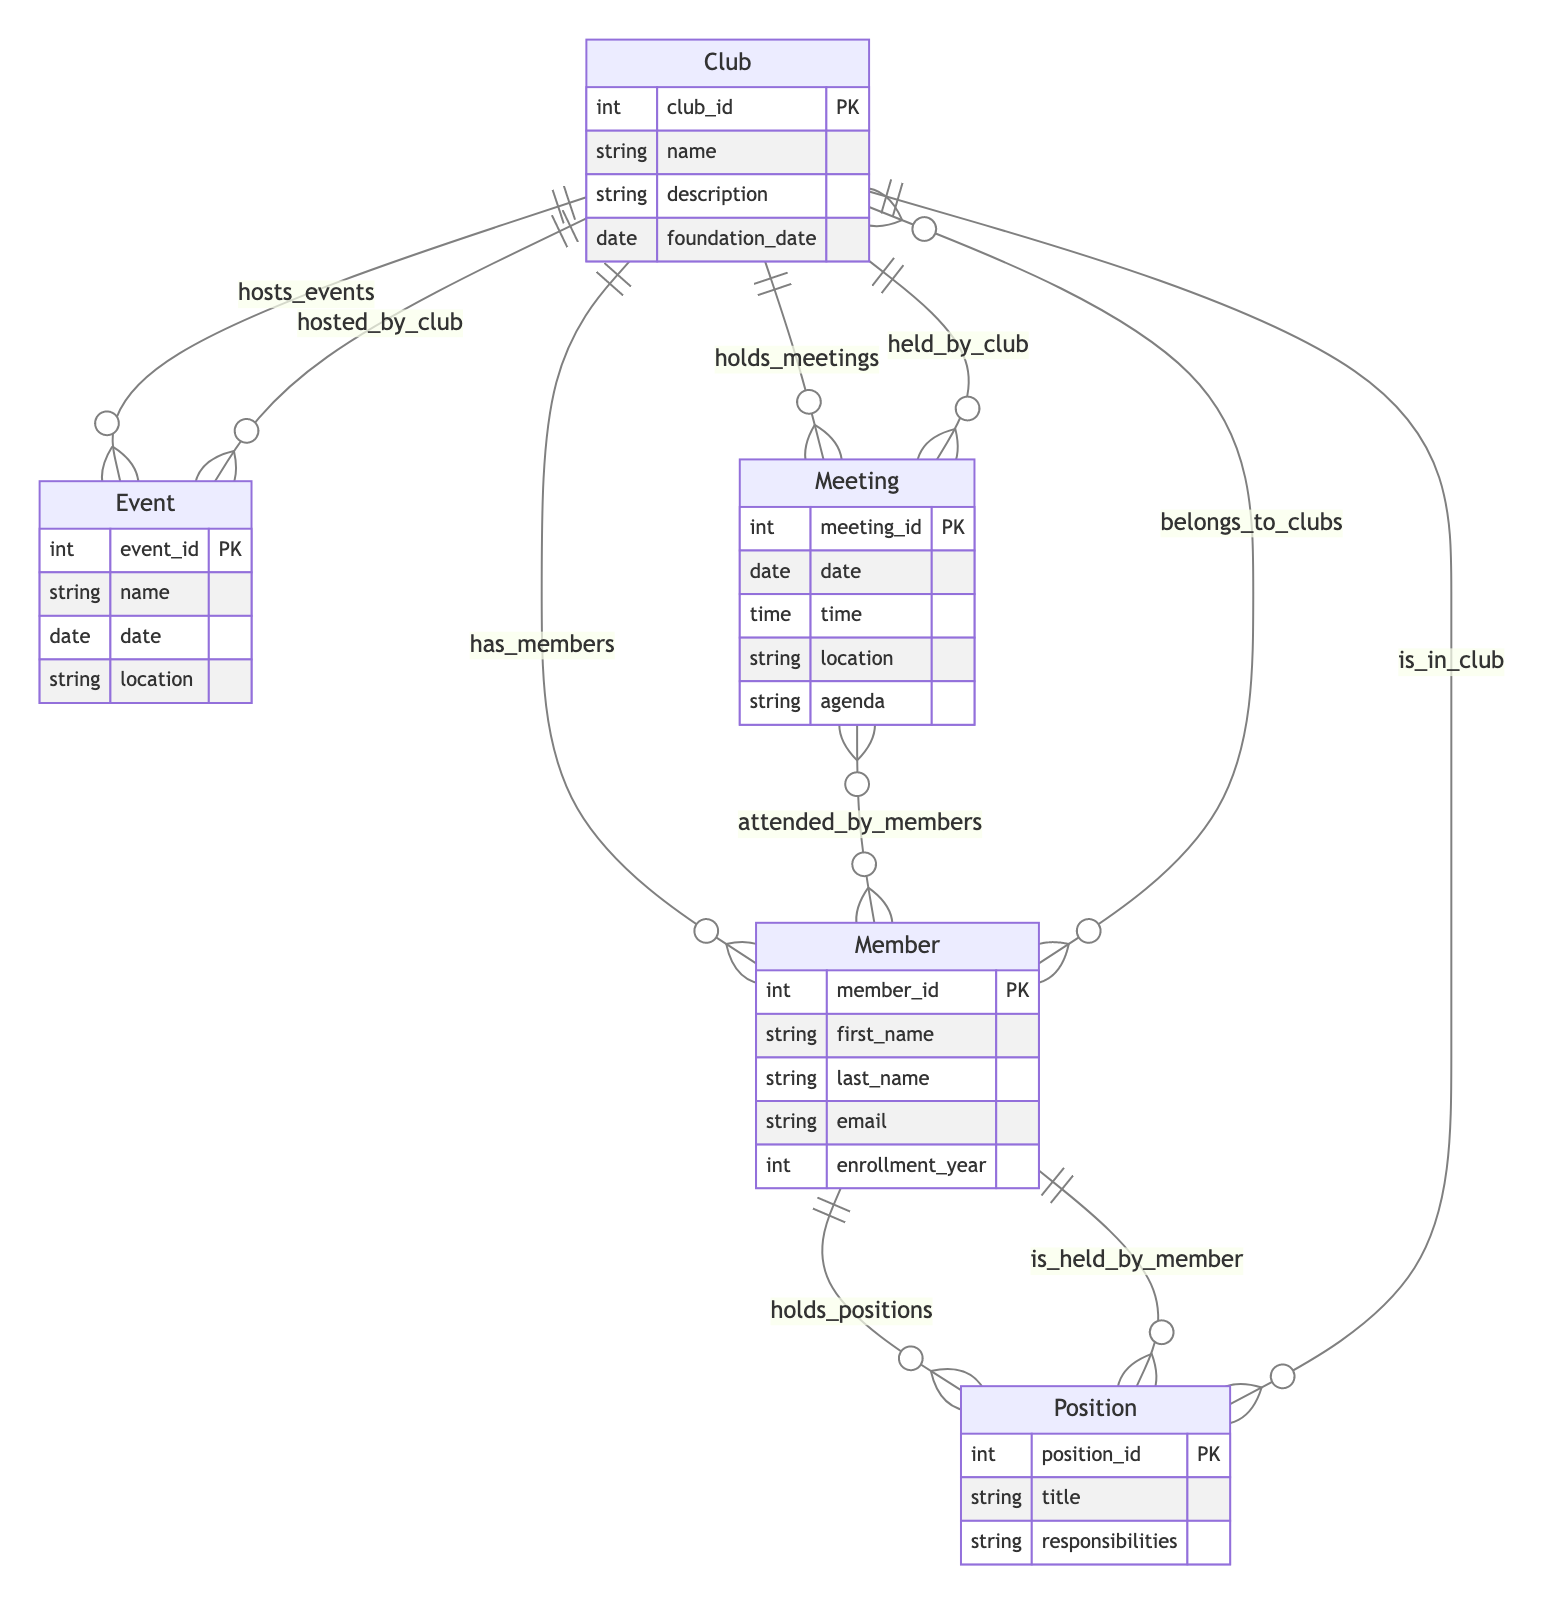What is the primary key attribute of the Club entity? The primary key attribute in the Club entity is specified as the 'club_id', which uniquely identifies each club.
Answer: club_id How many entities are represented in this diagram? The diagram includes five entities: Club, Member, Position, Event, and Meeting. Counting each gives us a total of five entities.
Answer: 5 Which entity is associated with the relationship "attended_by_members"? This relationship "attended_by_members" indicates that the Meeting entity is associated with members who attend meetings.
Answer: Meeting What is the attribute that defines the title of a position in the Position entity? In the Position entity, the attribute that defines the title is 'title', which describes the specific title of the position held by a member.
Answer: title How are clubs and members related according to the diagram? Clubs and members are related through multiple relationships, specifically, members "belong_to_clubs" and clubs "have_members," indicating a many-to-many relationship.
Answer: belongs_to_clubs Now, if a member holds a position, which two entities are involved in that relationship? The relationship involves the Member entity holding a Position, meaning that the two entities are Member and Position, highlighting the role members play within clubs.
Answer: Member and Position What relationship exists between an Event and a Club? The relationship between an Event and a Club is defined as "hosted_by_club", indicating that each event is hosted by a specific club.
Answer: hosted_by_club What is the relationship that links a Meeting to a Club? The Meeting is linked to a Club through the relationship "held_by_club", indicating that meetings are held by specific clubs.
Answer: held_by_club Which attribute of the Event entity specifies the location of the event? The attribute that specifies the location of the event in the Event entity is 'location', denoting where the event will take place.
Answer: location 